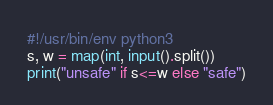Convert code to text. <code><loc_0><loc_0><loc_500><loc_500><_Python_>#!/usr/bin/env python3
s, w = map(int, input().split())
print("unsafe" if s<=w else "safe")</code> 